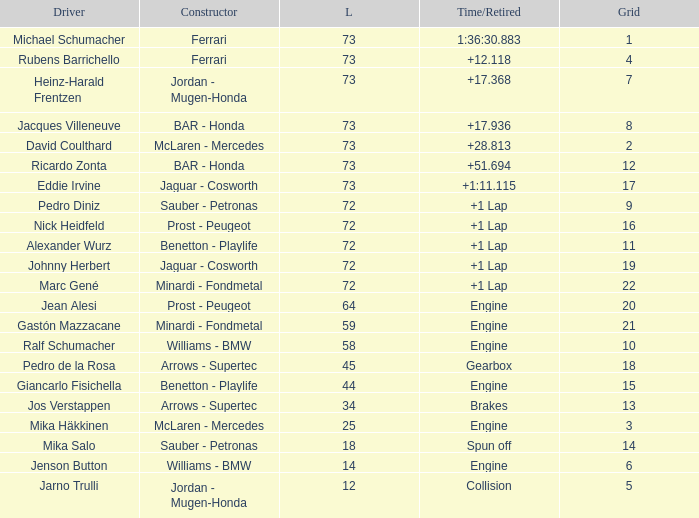Help me parse the entirety of this table. {'header': ['Driver', 'Constructor', 'L', 'Time/Retired', 'Grid'], 'rows': [['Michael Schumacher', 'Ferrari', '73', '1:36:30.883', '1'], ['Rubens Barrichello', 'Ferrari', '73', '+12.118', '4'], ['Heinz-Harald Frentzen', 'Jordan - Mugen-Honda', '73', '+17.368', '7'], ['Jacques Villeneuve', 'BAR - Honda', '73', '+17.936', '8'], ['David Coulthard', 'McLaren - Mercedes', '73', '+28.813', '2'], ['Ricardo Zonta', 'BAR - Honda', '73', '+51.694', '12'], ['Eddie Irvine', 'Jaguar - Cosworth', '73', '+1:11.115', '17'], ['Pedro Diniz', 'Sauber - Petronas', '72', '+1 Lap', '9'], ['Nick Heidfeld', 'Prost - Peugeot', '72', '+1 Lap', '16'], ['Alexander Wurz', 'Benetton - Playlife', '72', '+1 Lap', '11'], ['Johnny Herbert', 'Jaguar - Cosworth', '72', '+1 Lap', '19'], ['Marc Gené', 'Minardi - Fondmetal', '72', '+1 Lap', '22'], ['Jean Alesi', 'Prost - Peugeot', '64', 'Engine', '20'], ['Gastón Mazzacane', 'Minardi - Fondmetal', '59', 'Engine', '21'], ['Ralf Schumacher', 'Williams - BMW', '58', 'Engine', '10'], ['Pedro de la Rosa', 'Arrows - Supertec', '45', 'Gearbox', '18'], ['Giancarlo Fisichella', 'Benetton - Playlife', '44', 'Engine', '15'], ['Jos Verstappen', 'Arrows - Supertec', '34', 'Brakes', '13'], ['Mika Häkkinen', 'McLaren - Mercedes', '25', 'Engine', '3'], ['Mika Salo', 'Sauber - Petronas', '18', 'Spun off', '14'], ['Jenson Button', 'Williams - BMW', '14', 'Engine', '6'], ['Jarno Trulli', 'Jordan - Mugen-Honda', '12', 'Collision', '5']]} How many laps did Giancarlo Fisichella do with a grid larger than 15? 0.0. 